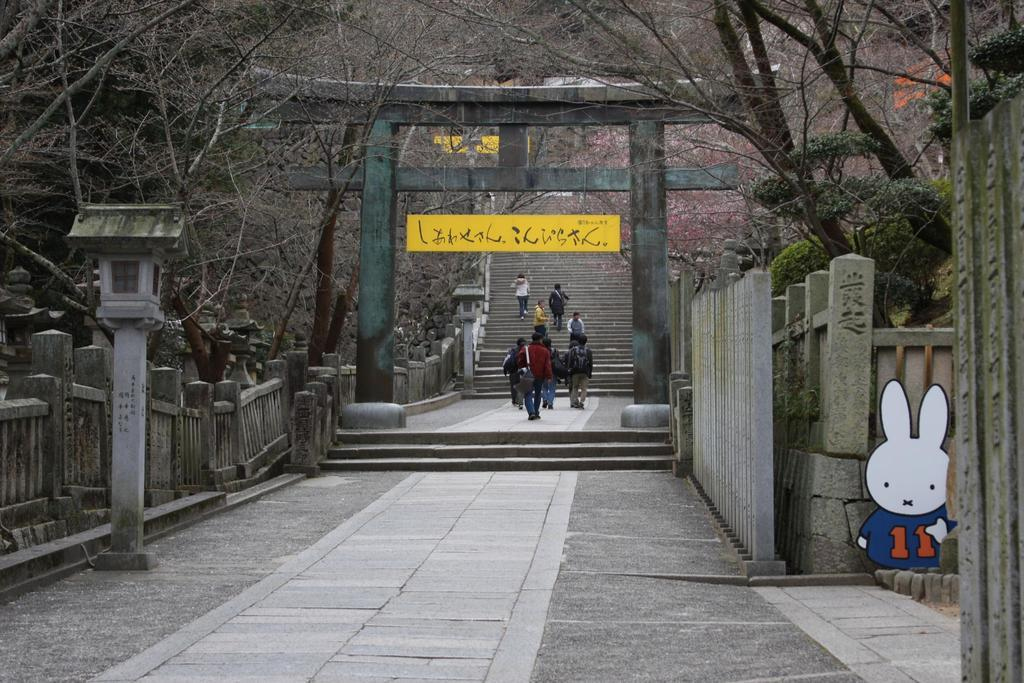What are the persons in the image doing? The persons in the image are climbing. What structure do the persons appear to be climbing? There are stairs in the image that the persons are climbing. What safety features are present in the image? There are railings in the image, which provide support and safety while climbing. What else can be seen in the image besides the persons climbing? There are poles in the image, and a toy is on the floor. What type of smell can be detected from the toy on the floor in the image? There is no information about the smell of the toy in the image, as the facts provided do not mention any sensory details. 